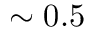Convert formula to latex. <formula><loc_0><loc_0><loc_500><loc_500>\sim 0 . 5</formula> 